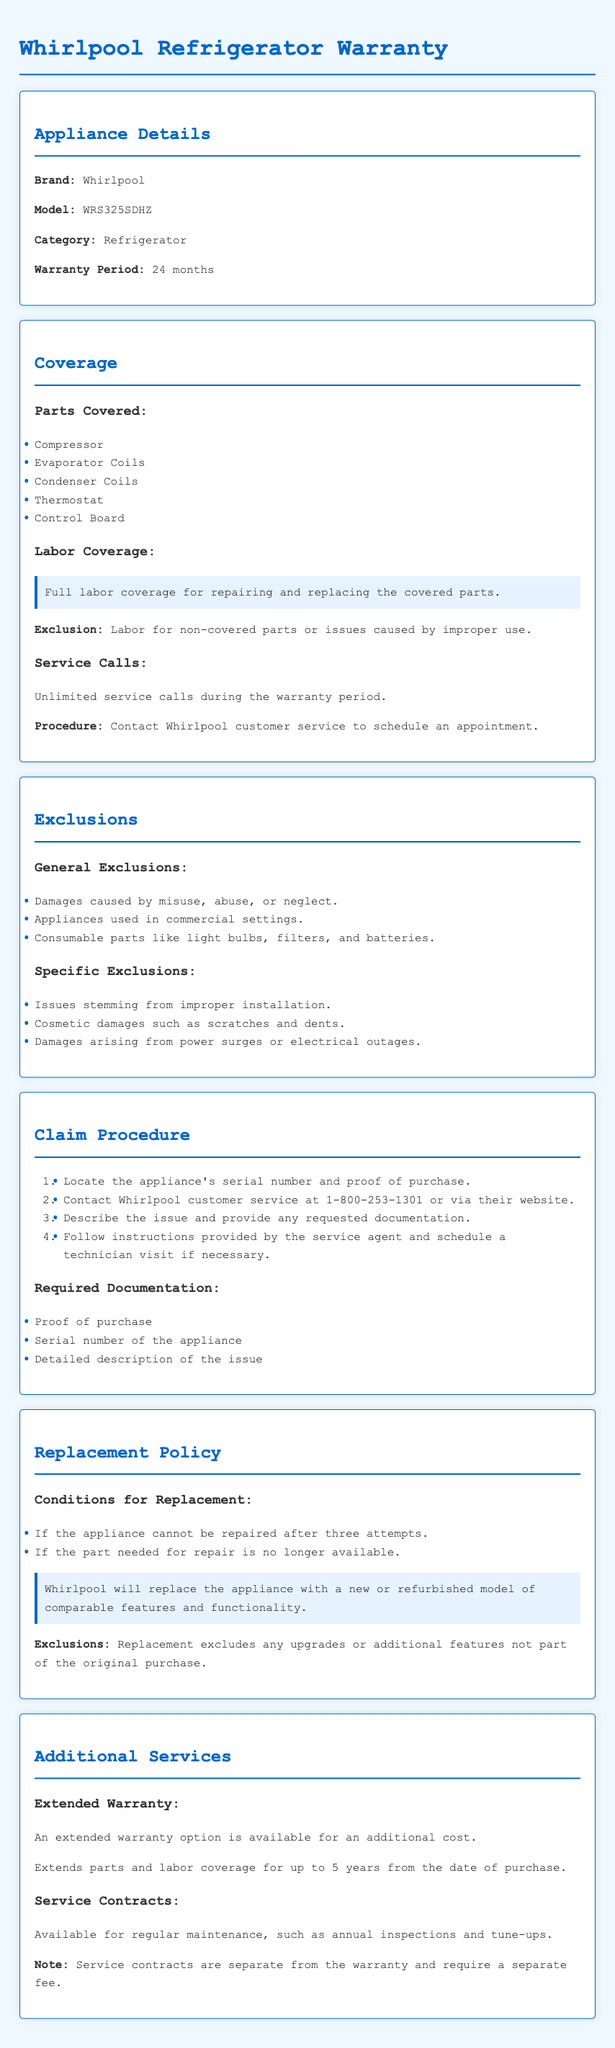What is the warranty period for the Whirlpool refrigerator? The warranty period is clearly stated in the document as 24 months.
Answer: 24 months What parts are covered under the warranty? The document lists specific parts covered under the warranty including the compressor, evaporator coils, and others.
Answer: Compressor, Evaporator Coils, Condenser Coils, Thermostat, Control Board What is the phone number for Whirlpool customer service? The claim procedure mentions the customer service number which is essential for claims.
Answer: 1-800-253-1301 How many service calls are allowed during the warranty period? The coverage section indicates the allowance for service calls during the warranty.
Answer: Unlimited What condition warrants a replacement of the appliance? The replacement policy outlines conditions that justify an appliance replacement after attempts to repair.
Answer: After three attempts What is specifically excluded from the warranty? The exclusions section enumerates general exclusions and specific exclusions that invalidate the warranty.
Answer: Misuse, abuse, or neglect What documentation is required to file a claim? The claim procedure specifies several documents needed to support a warranty claim.
Answer: Proof of purchase, Serial number, Detailed description of the issue Is there an option for an extended warranty? The additional services section mentions the availability of an extended warranty for further coverage.
Answer: Yes What does the extended warranty extend? The document states what the extended warranty covers and its duration.
Answer: Parts and labor coverage for up to 5 years 